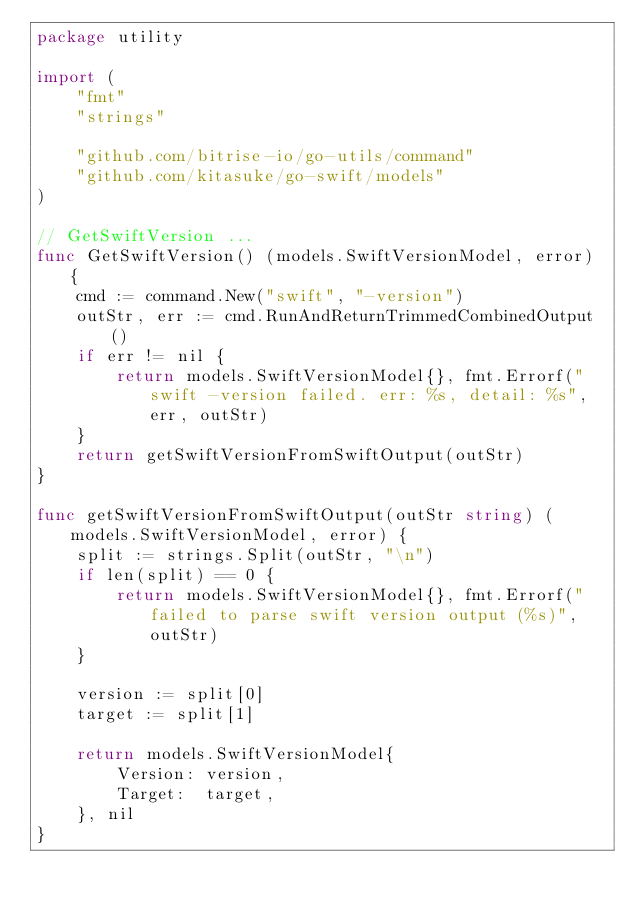Convert code to text. <code><loc_0><loc_0><loc_500><loc_500><_Go_>package utility

import (
	"fmt"
	"strings"

	"github.com/bitrise-io/go-utils/command"
	"github.com/kitasuke/go-swift/models"
)

// GetSwiftVersion ...
func GetSwiftVersion() (models.SwiftVersionModel, error) {
	cmd := command.New("swift", "-version")
	outStr, err := cmd.RunAndReturnTrimmedCombinedOutput()
	if err != nil {
		return models.SwiftVersionModel{}, fmt.Errorf("swift -version failed. err: %s, detail: %s", err, outStr)
	}
	return getSwiftVersionFromSwiftOutput(outStr)
}

func getSwiftVersionFromSwiftOutput(outStr string) (models.SwiftVersionModel, error) {
	split := strings.Split(outStr, "\n")
	if len(split) == 0 {
		return models.SwiftVersionModel{}, fmt.Errorf("failed to parse swift version output (%s)", outStr)
	}

	version := split[0]
	target := split[1]

	return models.SwiftVersionModel{
		Version: version,
		Target:  target,
	}, nil
}
</code> 